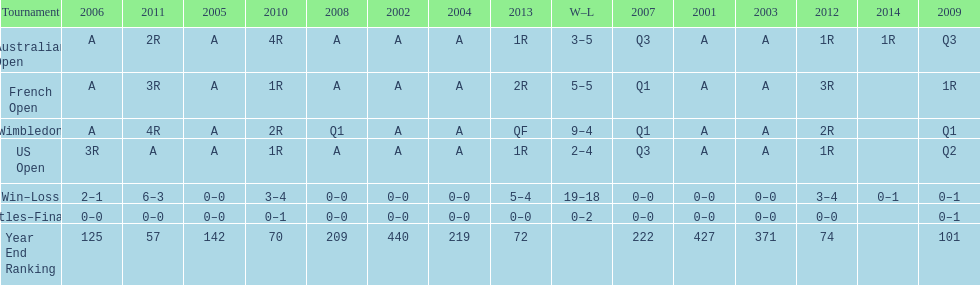In what years did only a single loss occur? 2006, 2009, 2014. 